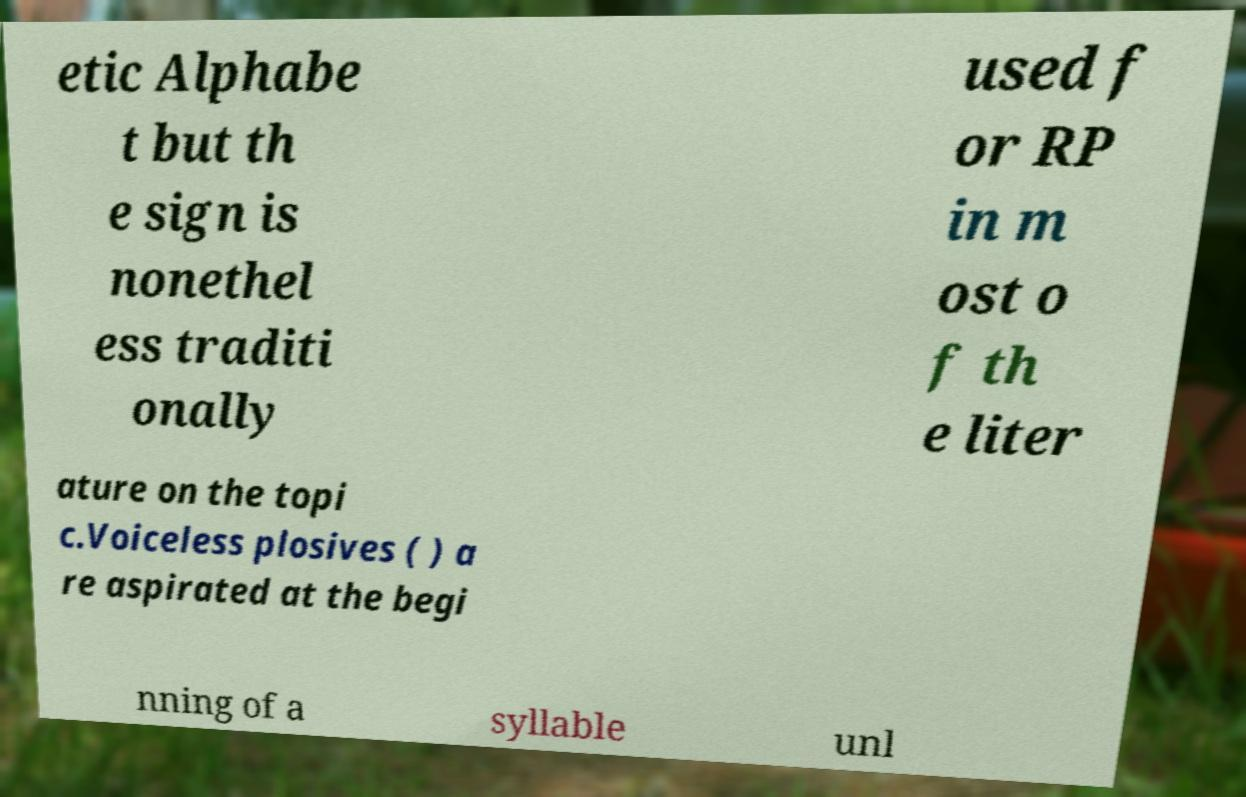Can you accurately transcribe the text from the provided image for me? etic Alphabe t but th e sign is nonethel ess traditi onally used f or RP in m ost o f th e liter ature on the topi c.Voiceless plosives ( ) a re aspirated at the begi nning of a syllable unl 